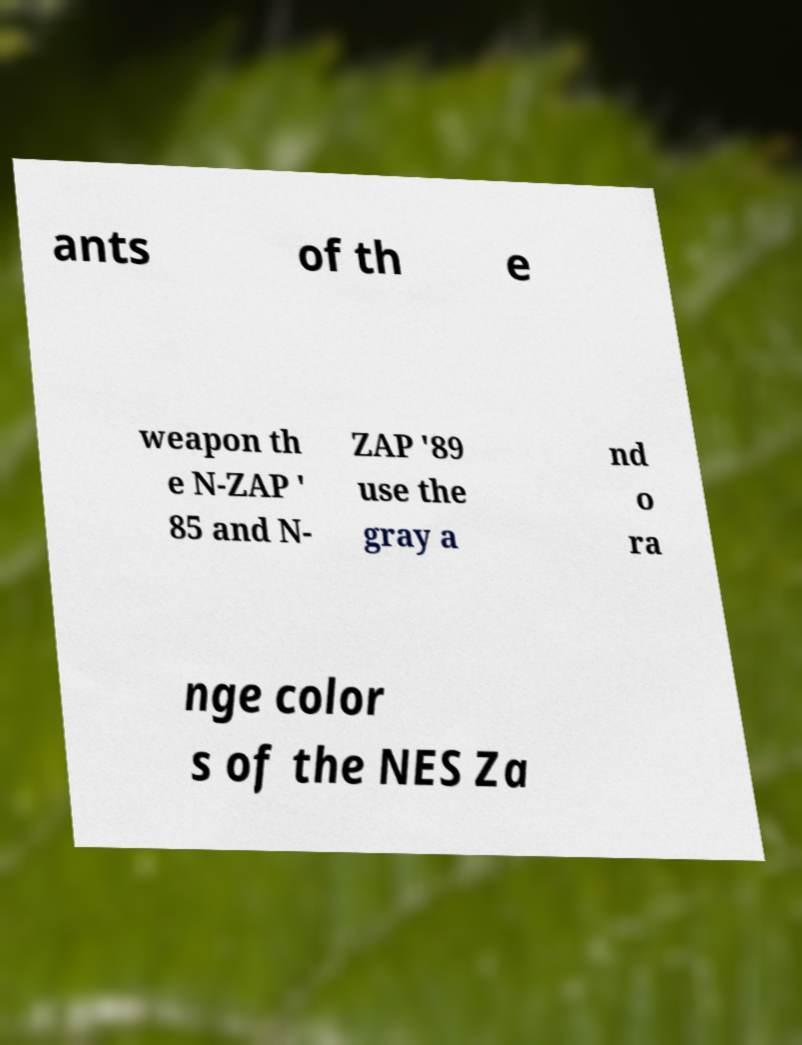Could you extract and type out the text from this image? ants of th e weapon th e N-ZAP ' 85 and N- ZAP '89 use the gray a nd o ra nge color s of the NES Za 